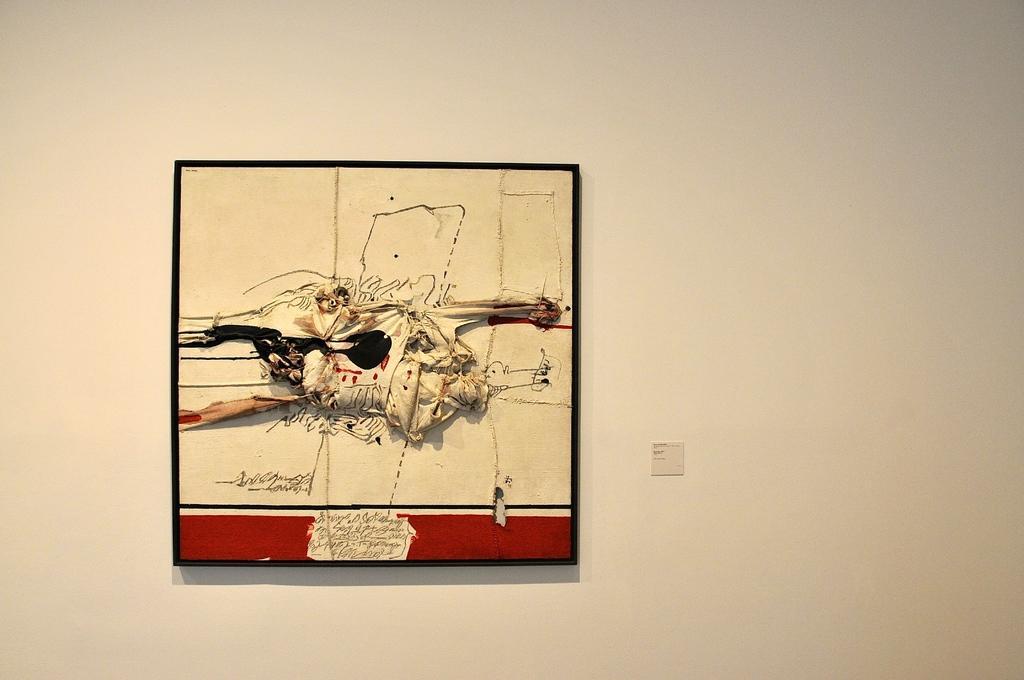In one or two sentences, can you explain what this image depicts? In this image I can see a frame which consists of a painting. At the bottom there is some text. This frame is attached to the wall. 